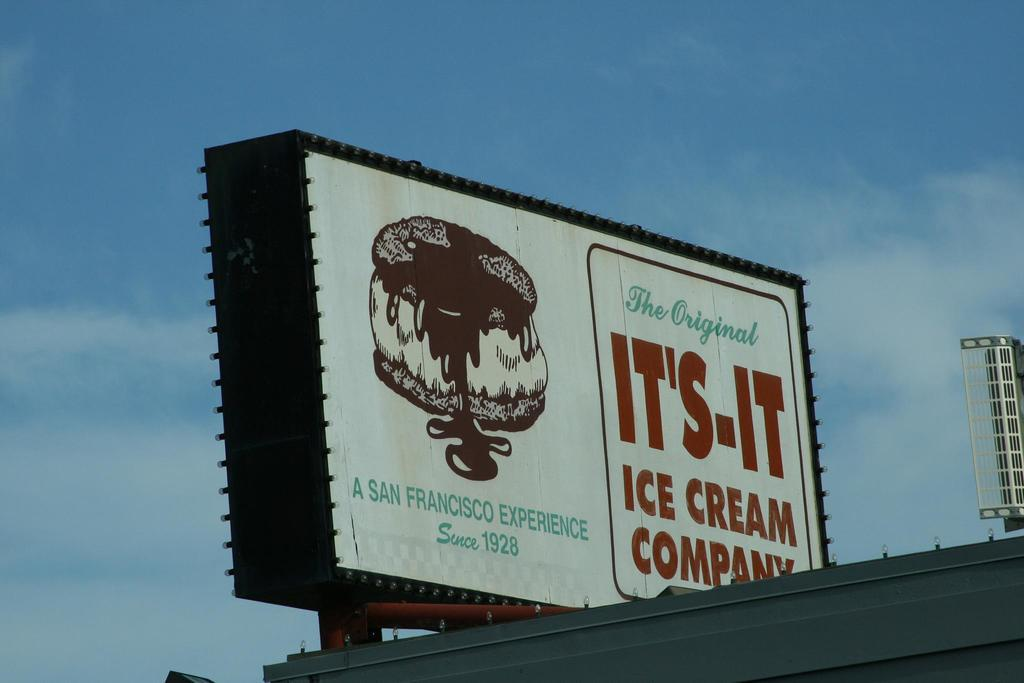What is the main subject in the image? There is a hoarding in the image. What can be seen in the background of the image? The sky is visible in the background of the image. How many hands are visible on the hoarding in the image? There are no hands visible on the hoarding in the image. What type of act is being performed on the hoarding in the image? There is no act being performed on the hoarding in the image; it is a static advertisement or sign. 